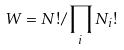<formula> <loc_0><loc_0><loc_500><loc_500>W = N ! / \prod _ { i } N _ { i } !</formula> 